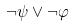Convert formula to latex. <formula><loc_0><loc_0><loc_500><loc_500>\neg \psi \vee \neg \varphi</formula> 